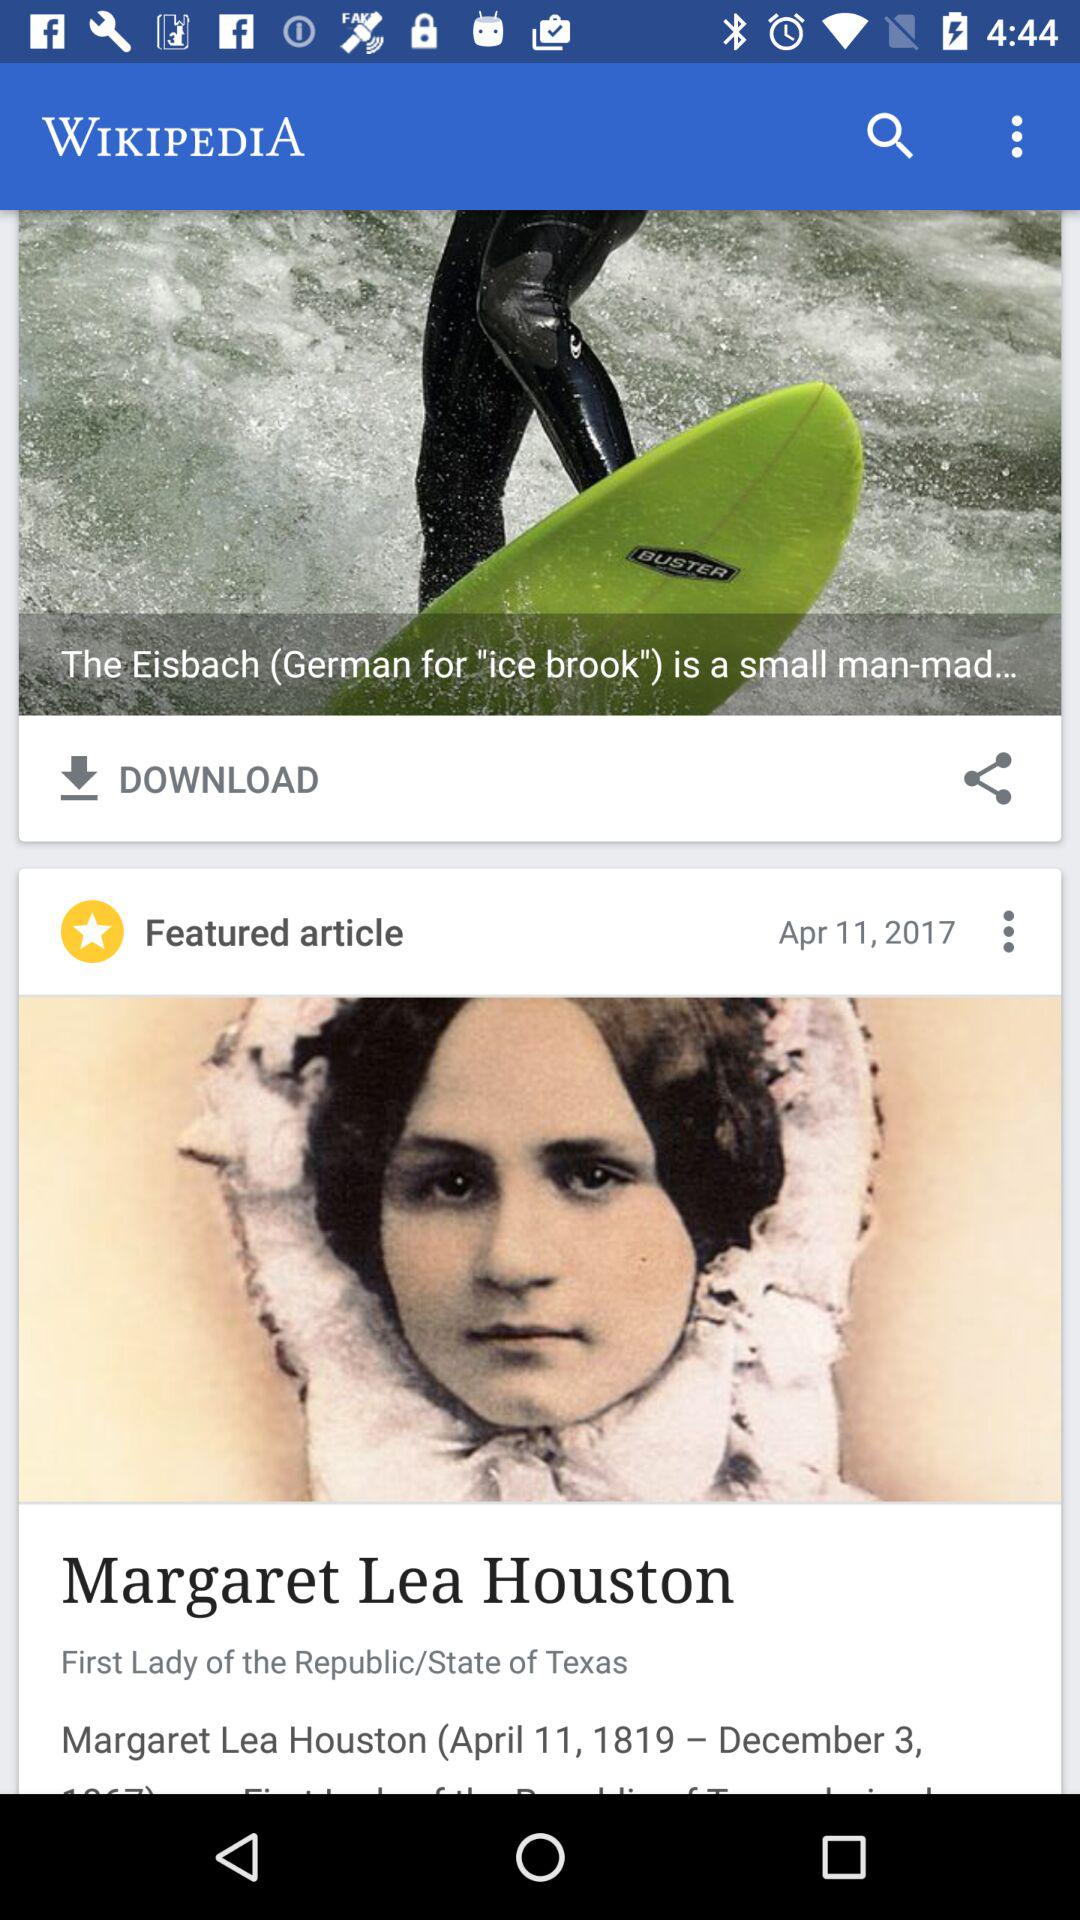What is the name of the application? The name of the application is "WIKIPEDIA". 